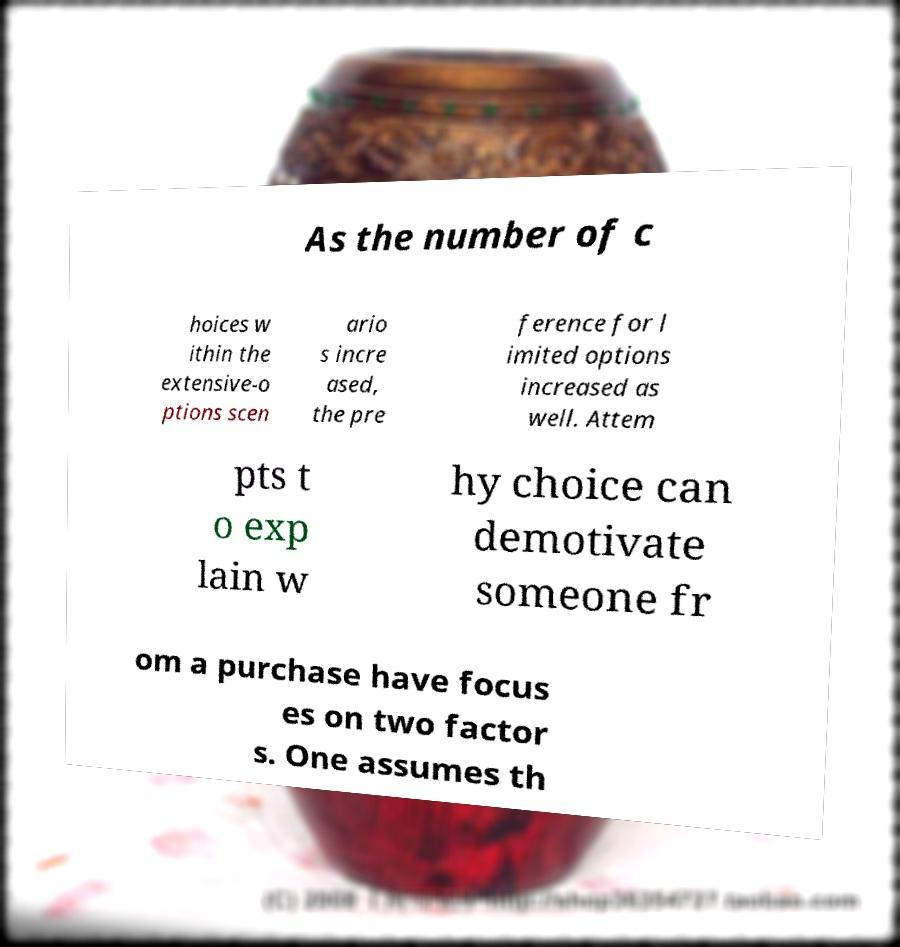Could you extract and type out the text from this image? As the number of c hoices w ithin the extensive-o ptions scen ario s incre ased, the pre ference for l imited options increased as well. Attem pts t o exp lain w hy choice can demotivate someone fr om a purchase have focus es on two factor s. One assumes th 